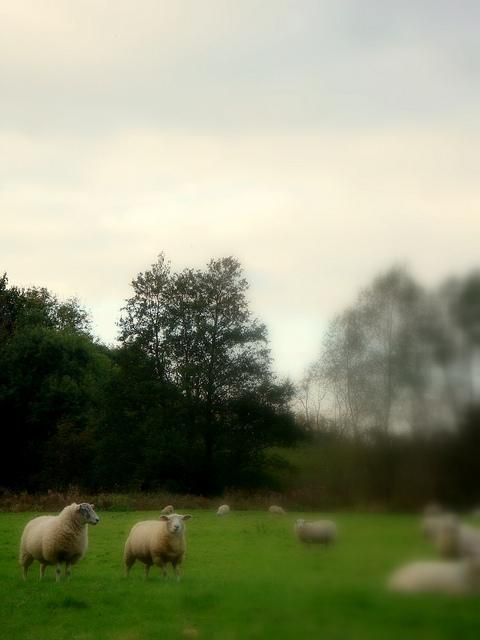What is the condition of the sky? cloudy 